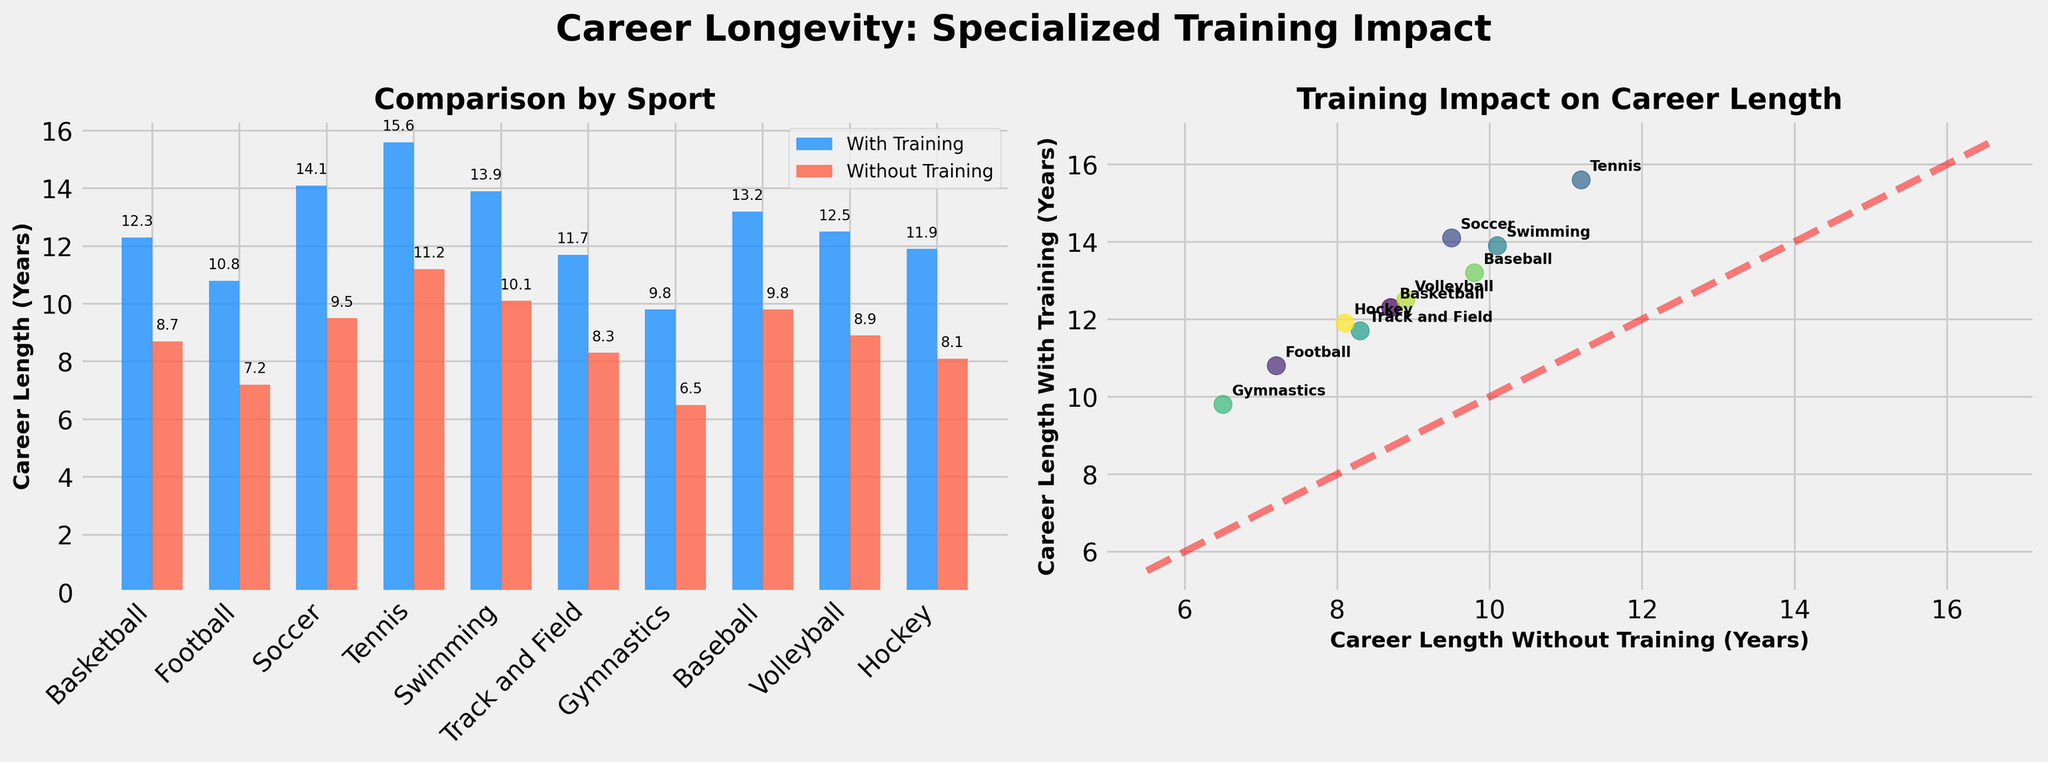Which sport has the longest career length with specialized training? The bar plot shows career lengths for different sports with and without specialized training. The longest bar in the 'With Training' group is for Tennis with 15.6 years.
Answer: Tennis Which sport has the smallest difference in career length between those with and without training? In the bar plot, you can visually compare the height difference between the bars for each sport. Gymnastics has the smallest difference, with 9.8 years with training and 6.5 years without training, giving a difference of 3.3 years.
Answer: Gymnastics How much longer, on average, do athletes with specialized training play compared to those without? Calculate the difference for each sport, sum these differences, and divide by the number of sports. Differences: Basketball = 3.6, Football = 3.6, Soccer = 4.6, Tennis = 4.4, Swimming = 3.8, Track and Field = 3.4, Gymnastics = 3.3, Baseball = 3.4, Volleyball = 3.6, Hockey = 3.8. Sum = 37, divide by 10 sports = 3.7 years.
Answer: 3.7 years Which sport has a more significant percentage increase in career length due to specialized training, Basketball or Football? Calculate the percentage increase for each sport: Basketball = (12.3 - 8.7) / 8.7 * 100 = 41.4%, Football = (10.8 - 7.2) / 7.2 * 100 = 50%. Football has a more significant percentage increase.
Answer: Football Are there any sports where the career length without training is longer than the one with training? Look for data points in the scatter plot that fall below the red dashed line (y=x). All points are above the line, indicating that in all sports, careers last longer with training than without.
Answer: No Which data points fall closest to the diagonal line y=x in the scatter plot? What might that imply? The point for Gymnastics lies closest to the line y=x, meaning the career length with training (9.8 years) is not vastly different from without training (6.5 years). The closer proximity to the line indicates a smaller impact of specialized training relative to other sports.
Answer: Gymnastics What is the career length without training for soccer? Refer to the bar for Soccer in the 'Without Training' section. The height of this bar reads 9.5 years.
Answer: 9.5 years Which sport has the highest variability in career length between those with and without specialized training? The visual difference in bar lengths on the bar plot indicates that Tennis has the highest difference (15.6 - 11.2 = 4.4 years), thus the highest variability.
Answer: Tennis Which sport benefits most from specialized training, according to the scatter plot? The sport furthest from the diagonal line in the scatter plot has the most significant difference. Tennis is the farthest above the line, indicating the greatest benefit from specialized training.
Answer: Tennis 